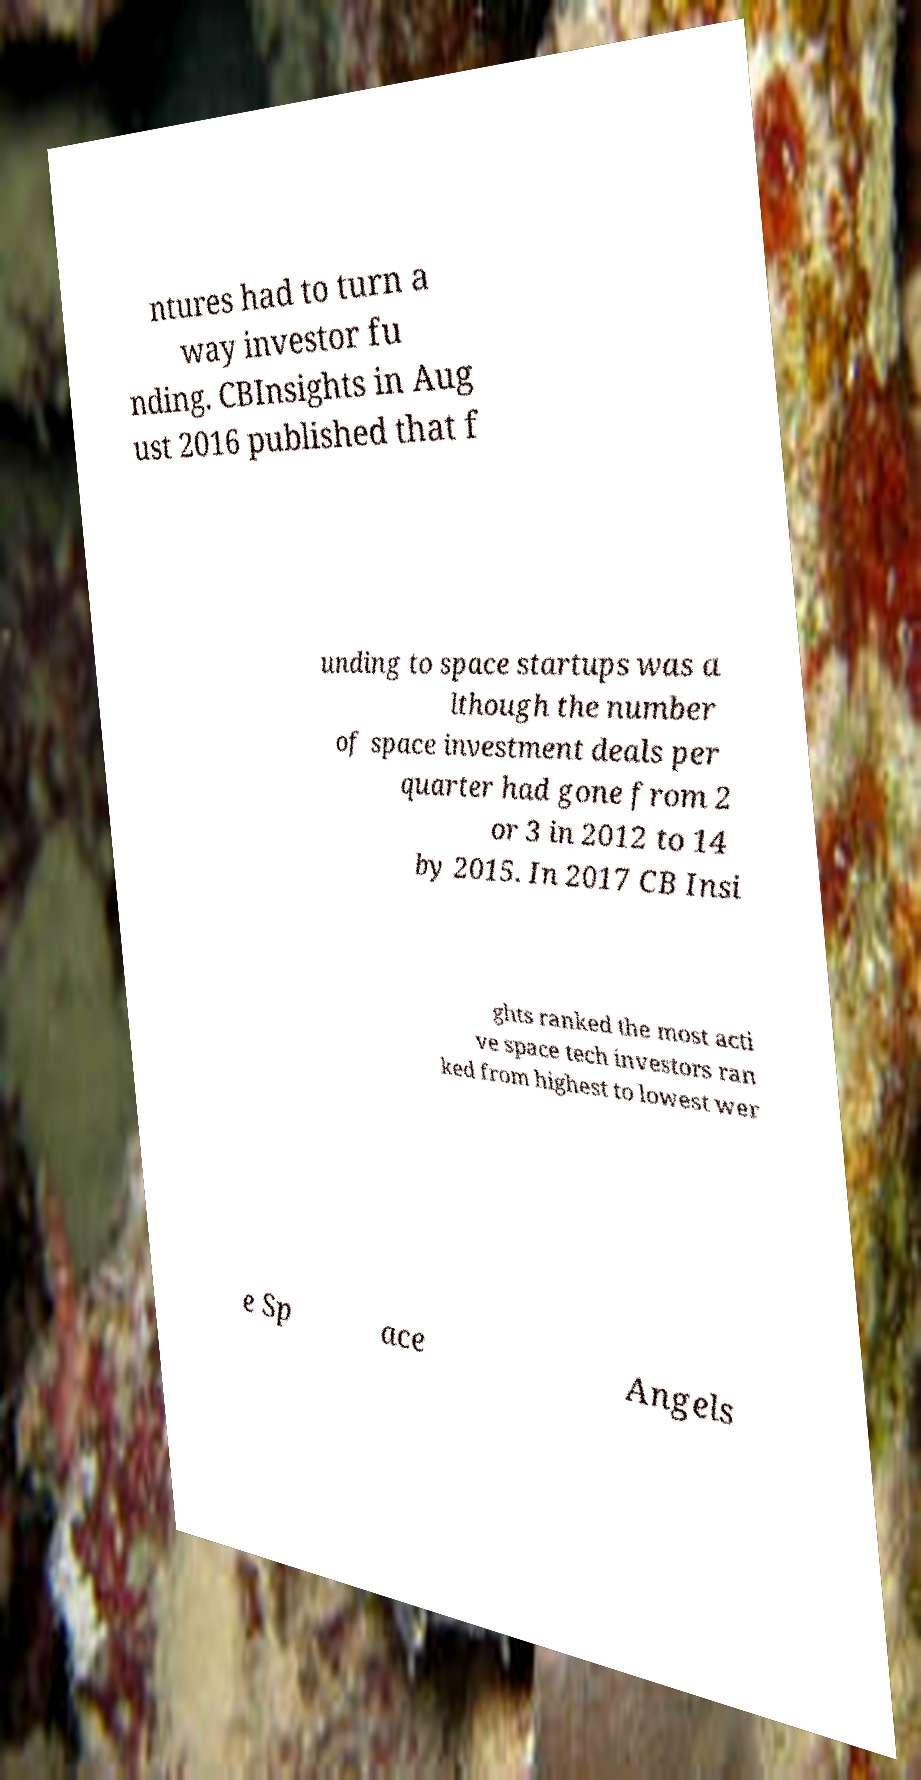Please identify and transcribe the text found in this image. ntures had to turn a way investor fu nding. CBInsights in Aug ust 2016 published that f unding to space startups was a lthough the number of space investment deals per quarter had gone from 2 or 3 in 2012 to 14 by 2015. In 2017 CB Insi ghts ranked the most acti ve space tech investors ran ked from highest to lowest wer e Sp ace Angels 